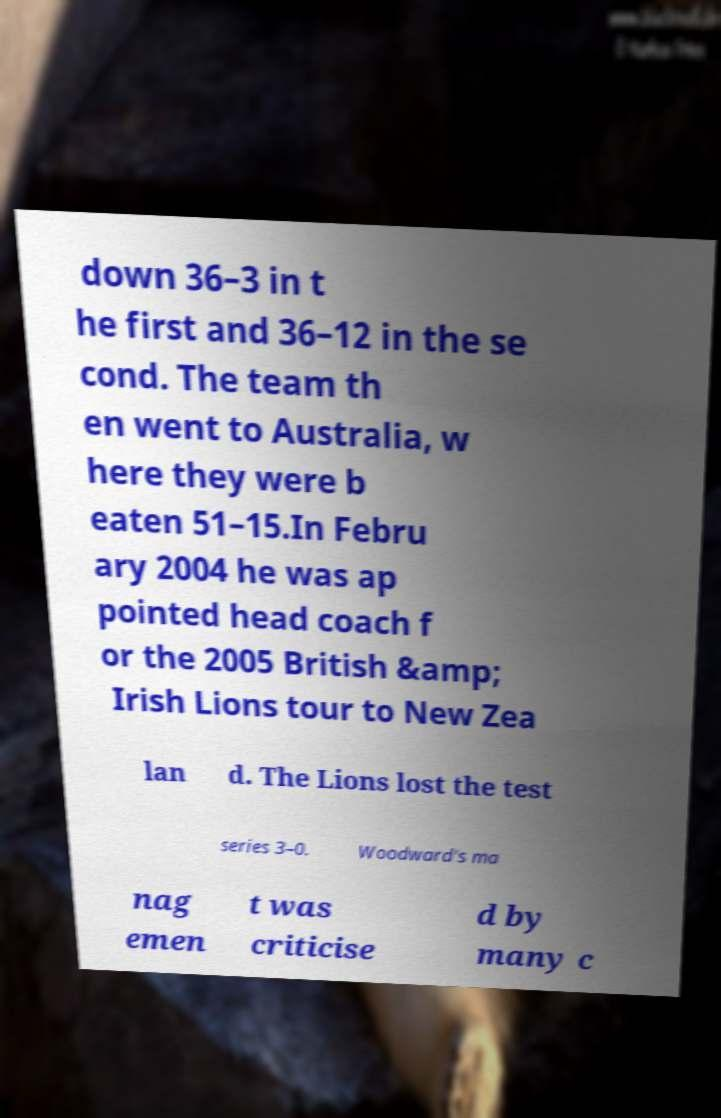Please identify and transcribe the text found in this image. down 36–3 in t he first and 36–12 in the se cond. The team th en went to Australia, w here they were b eaten 51–15.In Febru ary 2004 he was ap pointed head coach f or the 2005 British &amp; Irish Lions tour to New Zea lan d. The Lions lost the test series 3–0. Woodward's ma nag emen t was criticise d by many c 